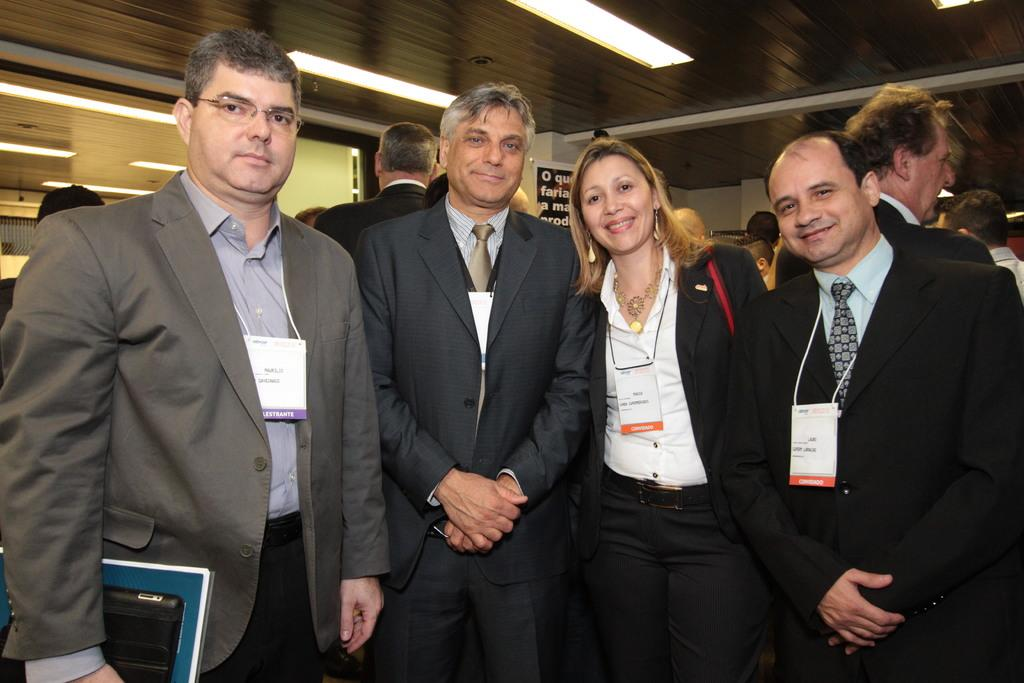What type of clothing are the persons in the image wearing? The persons in the image are wearing suits. What is the facial expression of the persons in suits? The persons in suits are smiling. What position are the persons in suits in? The persons in suits are standing. Can you describe the background of the image? There are other persons in the background of the image. What is attached to the roof in the image? There are lights attached to the roof in the image. Where is the library located in the image? There is no library present in the image. What type of crown is worn by the person in the center of the image? There is no crown present in the image. 